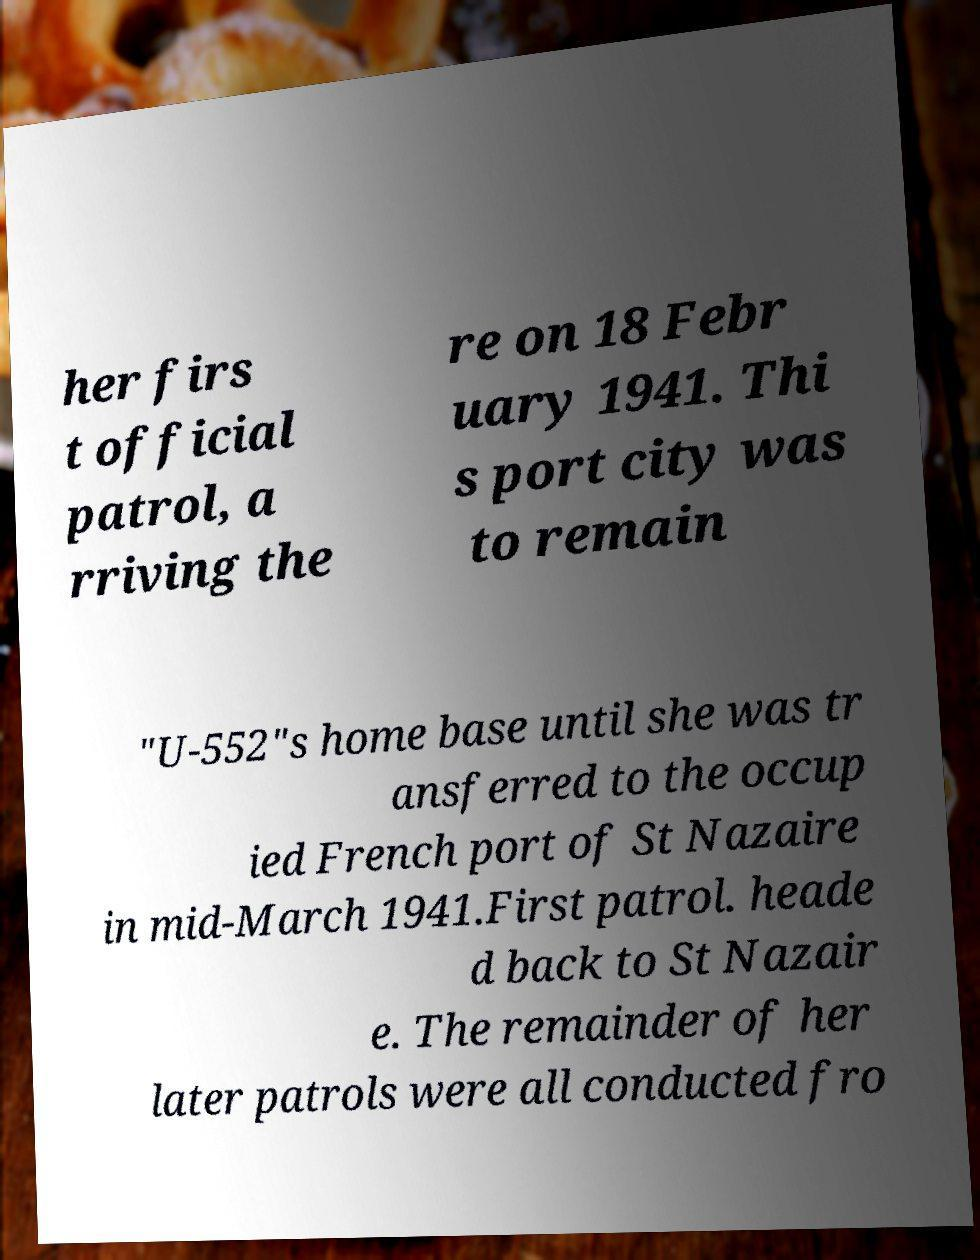Please read and relay the text visible in this image. What does it say? her firs t official patrol, a rriving the re on 18 Febr uary 1941. Thi s port city was to remain "U-552"s home base until she was tr ansferred to the occup ied French port of St Nazaire in mid-March 1941.First patrol. heade d back to St Nazair e. The remainder of her later patrols were all conducted fro 